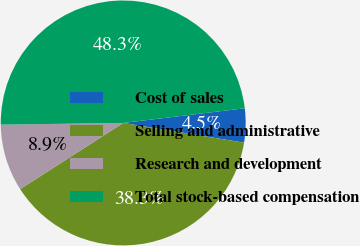Convert chart to OTSL. <chart><loc_0><loc_0><loc_500><loc_500><pie_chart><fcel>Cost of sales<fcel>Selling and administrative<fcel>Research and development<fcel>Total stock-based compensation<nl><fcel>4.49%<fcel>38.34%<fcel>8.87%<fcel>48.3%<nl></chart> 